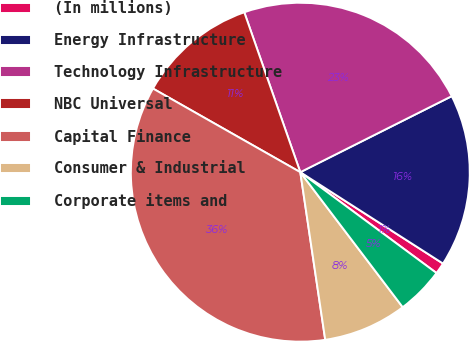Convert chart. <chart><loc_0><loc_0><loc_500><loc_500><pie_chart><fcel>(In millions)<fcel>Energy Infrastructure<fcel>Technology Infrastructure<fcel>NBC Universal<fcel>Capital Finance<fcel>Consumer & Industrial<fcel>Corporate items and<nl><fcel>1.08%<fcel>16.47%<fcel>22.96%<fcel>11.42%<fcel>35.57%<fcel>7.98%<fcel>4.53%<nl></chart> 